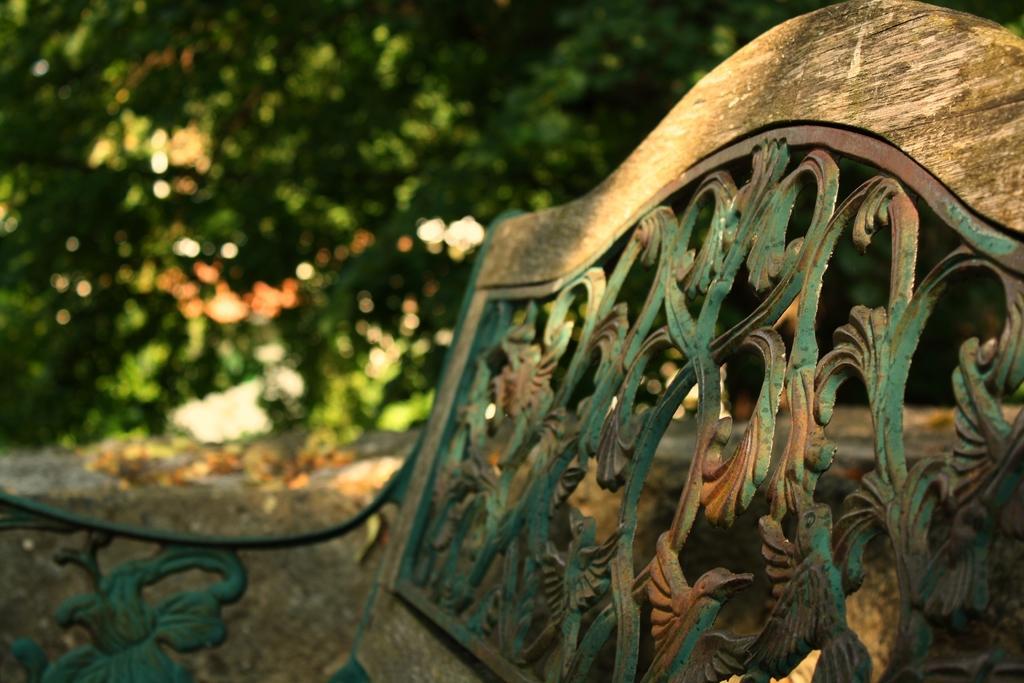Could you give a brief overview of what you see in this image? In this image we can see a bench with some design. In the background it is green and blur. 